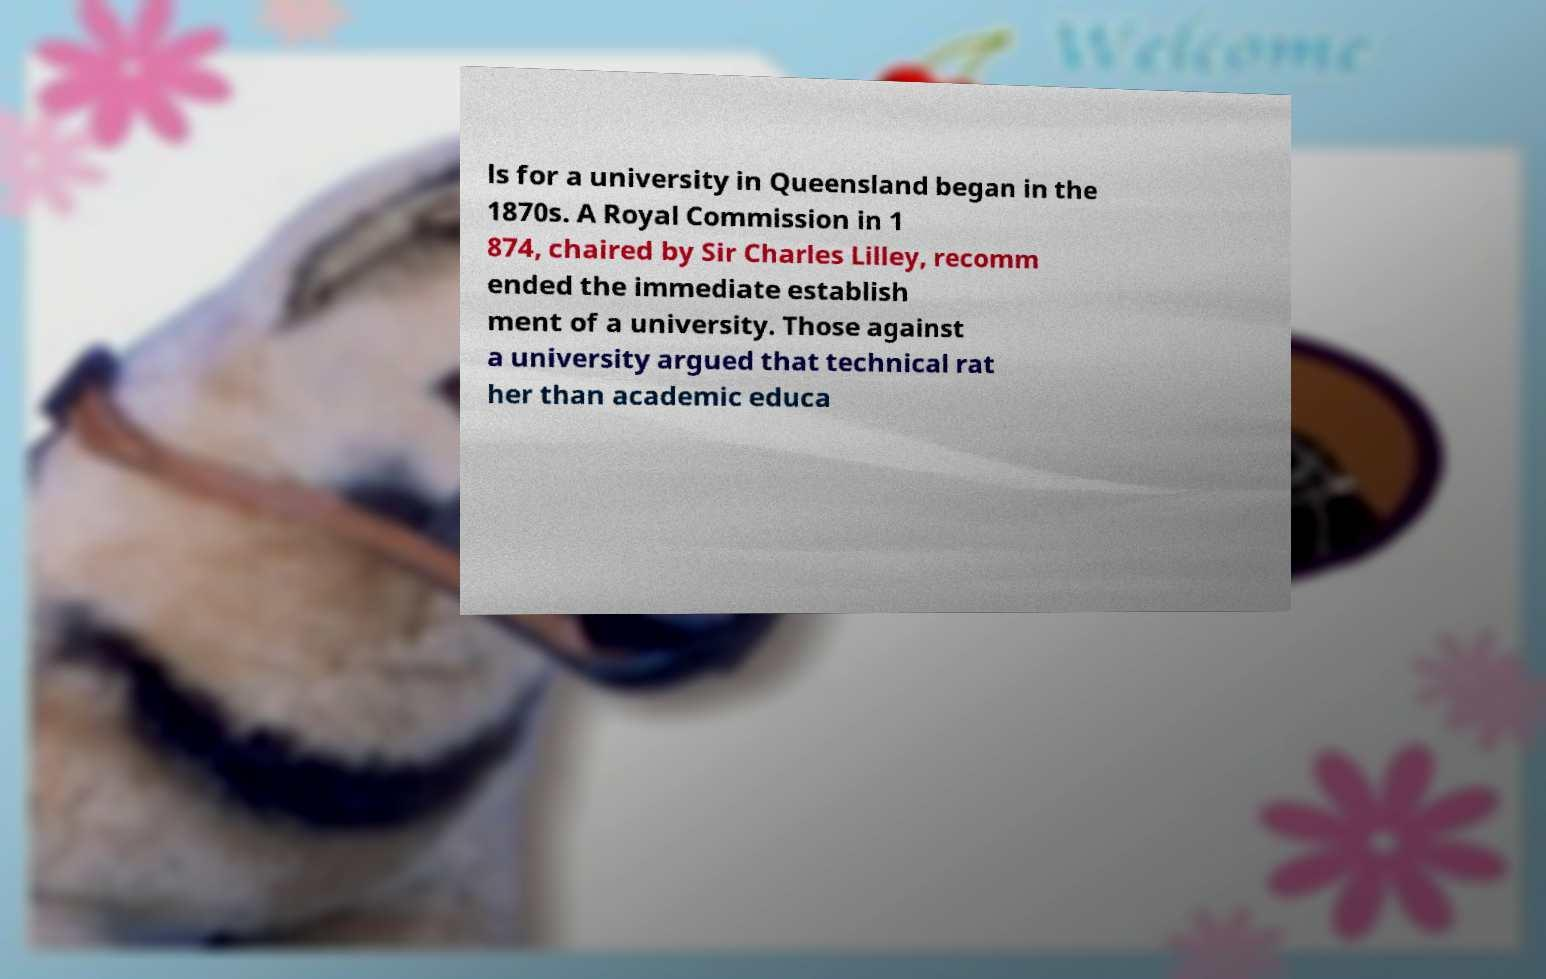Please read and relay the text visible in this image. What does it say? ls for a university in Queensland began in the 1870s. A Royal Commission in 1 874, chaired by Sir Charles Lilley, recomm ended the immediate establish ment of a university. Those against a university argued that technical rat her than academic educa 